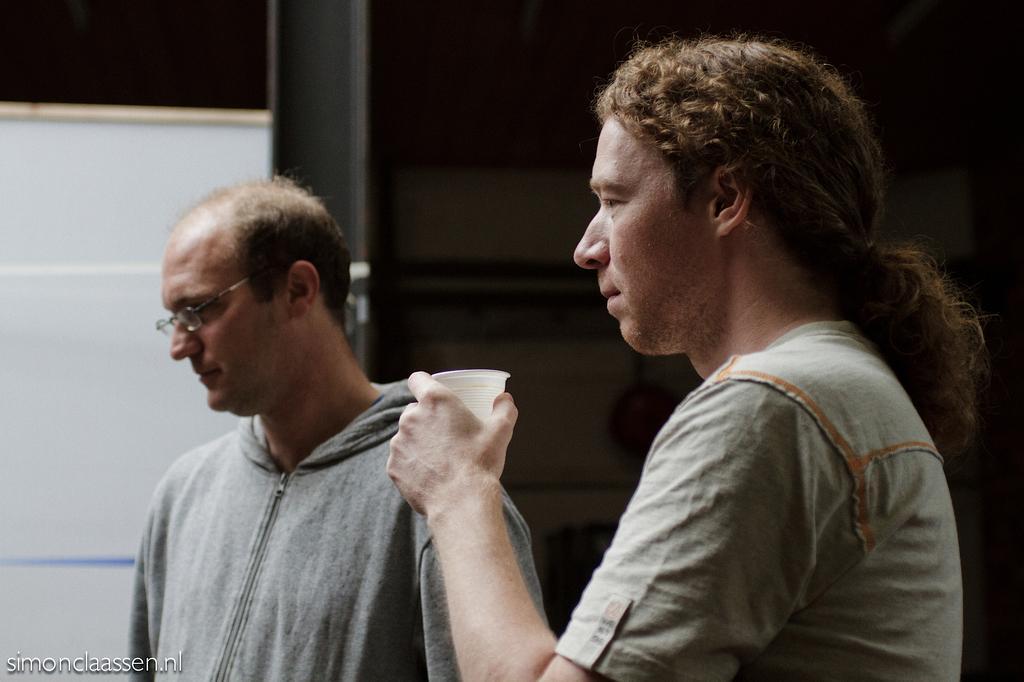Please provide a concise description of this image. In the picture I can see two men are standing among them the man on the right side is holding a glass in the hand. On the bottom left side of the image I can see a watermark. 